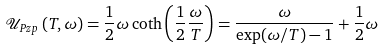<formula> <loc_0><loc_0><loc_500><loc_500>\mathcal { U } _ { P z p } \left ( T , \omega \right ) = \frac { 1 } { 2 } \omega \coth \left ( \frac { 1 } { 2 } \frac { \omega } { T } \right ) = \frac { \omega } { \exp ( \omega / T ) - 1 } + \frac { 1 } { 2 } \omega</formula> 